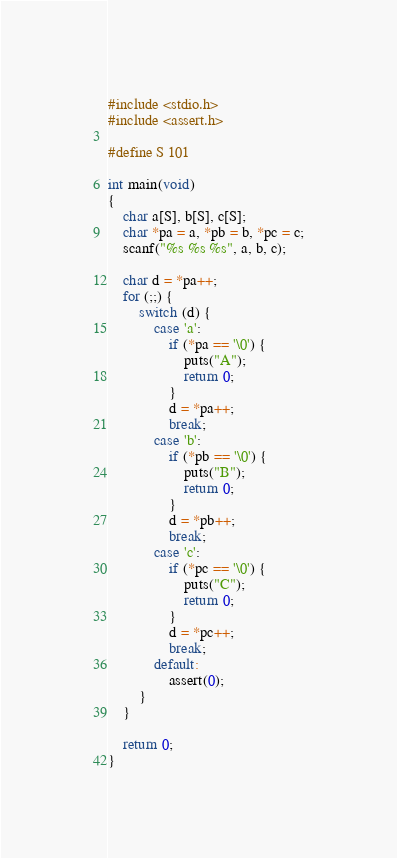<code> <loc_0><loc_0><loc_500><loc_500><_C_>#include <stdio.h>
#include <assert.h>

#define S 101

int main(void)
{
    char a[S], b[S], c[S];
    char *pa = a, *pb = b, *pc = c;
    scanf("%s %s %s", a, b, c);

    char d = *pa++;
    for (;;) {
        switch (d) {
            case 'a':
                if (*pa == '\0') {
                    puts("A");
                    return 0;
                }
                d = *pa++;
                break;
            case 'b':
                if (*pb == '\0') {
                    puts("B");
                    return 0;
                }
                d = *pb++;
                break;
            case 'c':
                if (*pc == '\0') {
                    puts("C");
                    return 0;
                }
                d = *pc++;
                break;
            default:
                assert(0);
        }
    }

    return 0;
}
</code> 